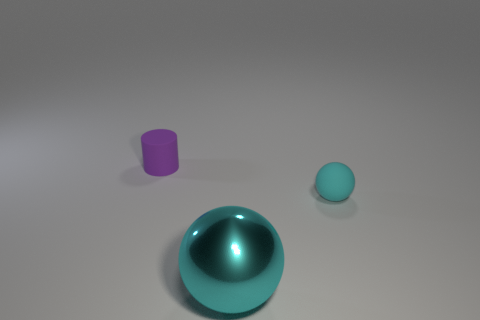Add 3 big cyan things. How many objects exist? 6 Subtract all cylinders. How many objects are left? 2 Add 1 tiny matte cylinders. How many tiny matte cylinders exist? 2 Subtract 0 gray blocks. How many objects are left? 3 Subtract all large cyan shiny spheres. Subtract all big metal objects. How many objects are left? 1 Add 2 cyan rubber things. How many cyan rubber things are left? 3 